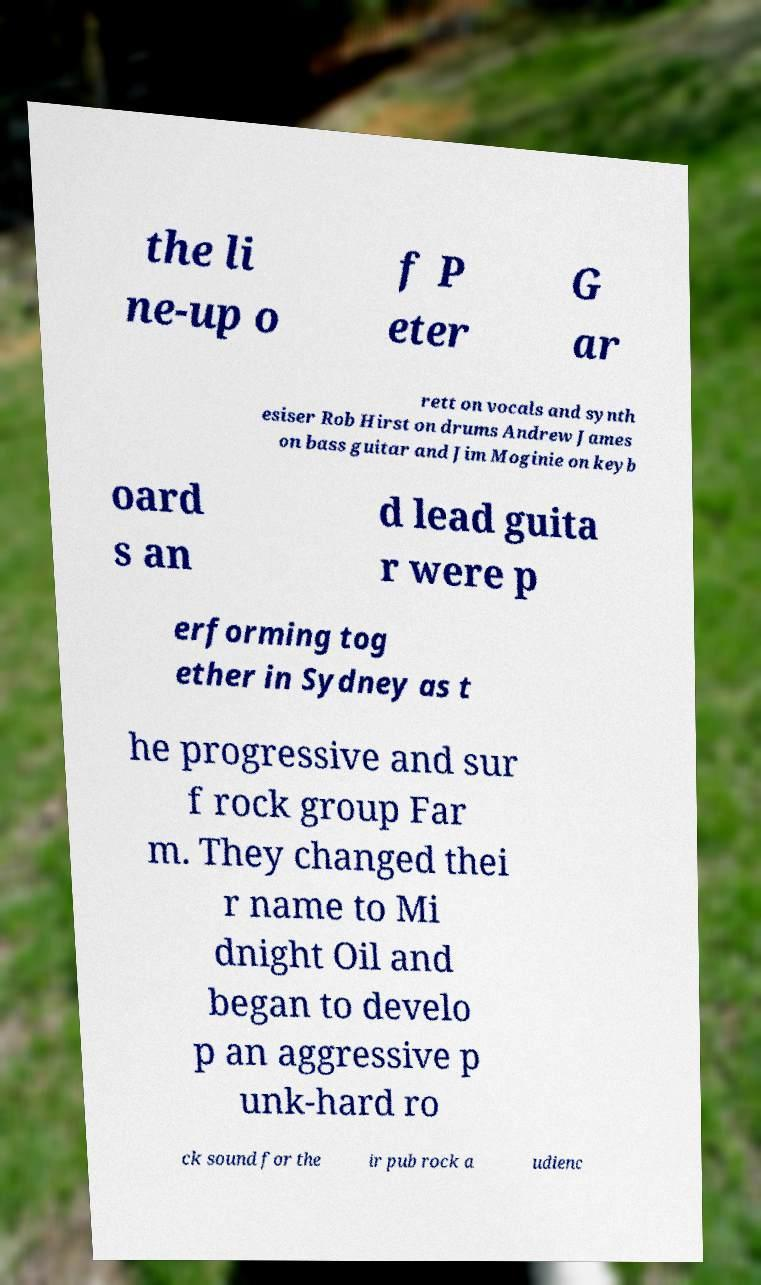For documentation purposes, I need the text within this image transcribed. Could you provide that? the li ne-up o f P eter G ar rett on vocals and synth esiser Rob Hirst on drums Andrew James on bass guitar and Jim Moginie on keyb oard s an d lead guita r were p erforming tog ether in Sydney as t he progressive and sur f rock group Far m. They changed thei r name to Mi dnight Oil and began to develo p an aggressive p unk-hard ro ck sound for the ir pub rock a udienc 